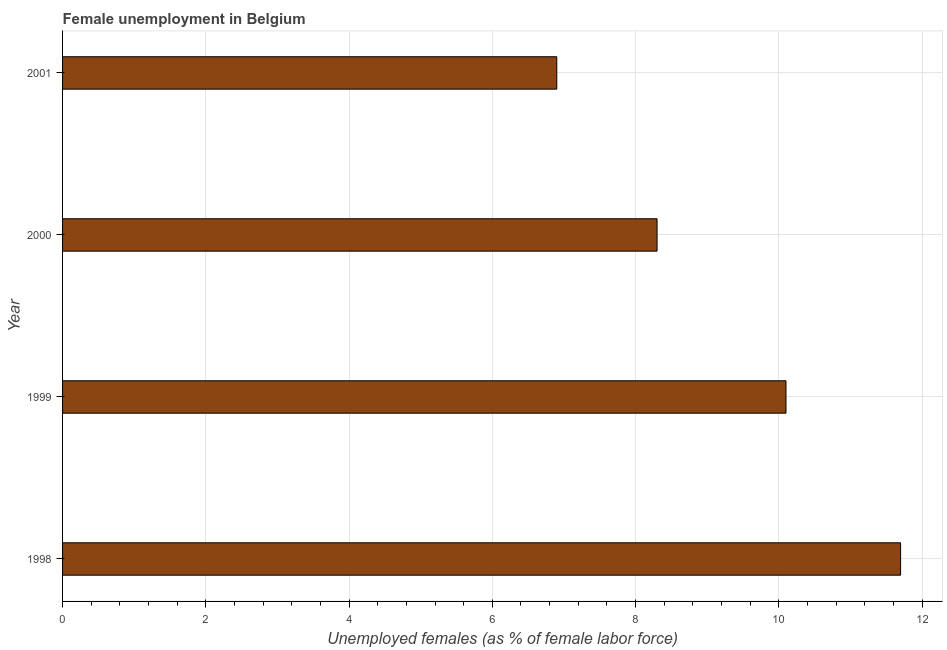Does the graph contain any zero values?
Provide a succinct answer. No. What is the title of the graph?
Offer a terse response. Female unemployment in Belgium. What is the label or title of the X-axis?
Offer a terse response. Unemployed females (as % of female labor force). What is the unemployed females population in 1999?
Provide a succinct answer. 10.1. Across all years, what is the maximum unemployed females population?
Provide a succinct answer. 11.7. Across all years, what is the minimum unemployed females population?
Your answer should be very brief. 6.9. In which year was the unemployed females population maximum?
Ensure brevity in your answer.  1998. What is the sum of the unemployed females population?
Your answer should be very brief. 37. What is the average unemployed females population per year?
Provide a succinct answer. 9.25. What is the median unemployed females population?
Keep it short and to the point. 9.2. In how many years, is the unemployed females population greater than 7.2 %?
Provide a short and direct response. 3. Do a majority of the years between 1999 and 2000 (inclusive) have unemployed females population greater than 4 %?
Ensure brevity in your answer.  Yes. What is the ratio of the unemployed females population in 1998 to that in 2000?
Provide a short and direct response. 1.41. Is the unemployed females population in 1998 less than that in 2001?
Keep it short and to the point. No. What is the difference between the highest and the lowest unemployed females population?
Make the answer very short. 4.8. How many bars are there?
Ensure brevity in your answer.  4. How many years are there in the graph?
Your answer should be compact. 4. What is the Unemployed females (as % of female labor force) in 1998?
Your answer should be compact. 11.7. What is the Unemployed females (as % of female labor force) of 1999?
Your response must be concise. 10.1. What is the Unemployed females (as % of female labor force) of 2000?
Keep it short and to the point. 8.3. What is the Unemployed females (as % of female labor force) in 2001?
Give a very brief answer. 6.9. What is the difference between the Unemployed females (as % of female labor force) in 1998 and 2000?
Your answer should be very brief. 3.4. What is the difference between the Unemployed females (as % of female labor force) in 1998 and 2001?
Offer a very short reply. 4.8. What is the difference between the Unemployed females (as % of female labor force) in 1999 and 2000?
Your answer should be compact. 1.8. What is the ratio of the Unemployed females (as % of female labor force) in 1998 to that in 1999?
Keep it short and to the point. 1.16. What is the ratio of the Unemployed females (as % of female labor force) in 1998 to that in 2000?
Provide a short and direct response. 1.41. What is the ratio of the Unemployed females (as % of female labor force) in 1998 to that in 2001?
Keep it short and to the point. 1.7. What is the ratio of the Unemployed females (as % of female labor force) in 1999 to that in 2000?
Make the answer very short. 1.22. What is the ratio of the Unemployed females (as % of female labor force) in 1999 to that in 2001?
Your answer should be very brief. 1.46. What is the ratio of the Unemployed females (as % of female labor force) in 2000 to that in 2001?
Your answer should be very brief. 1.2. 